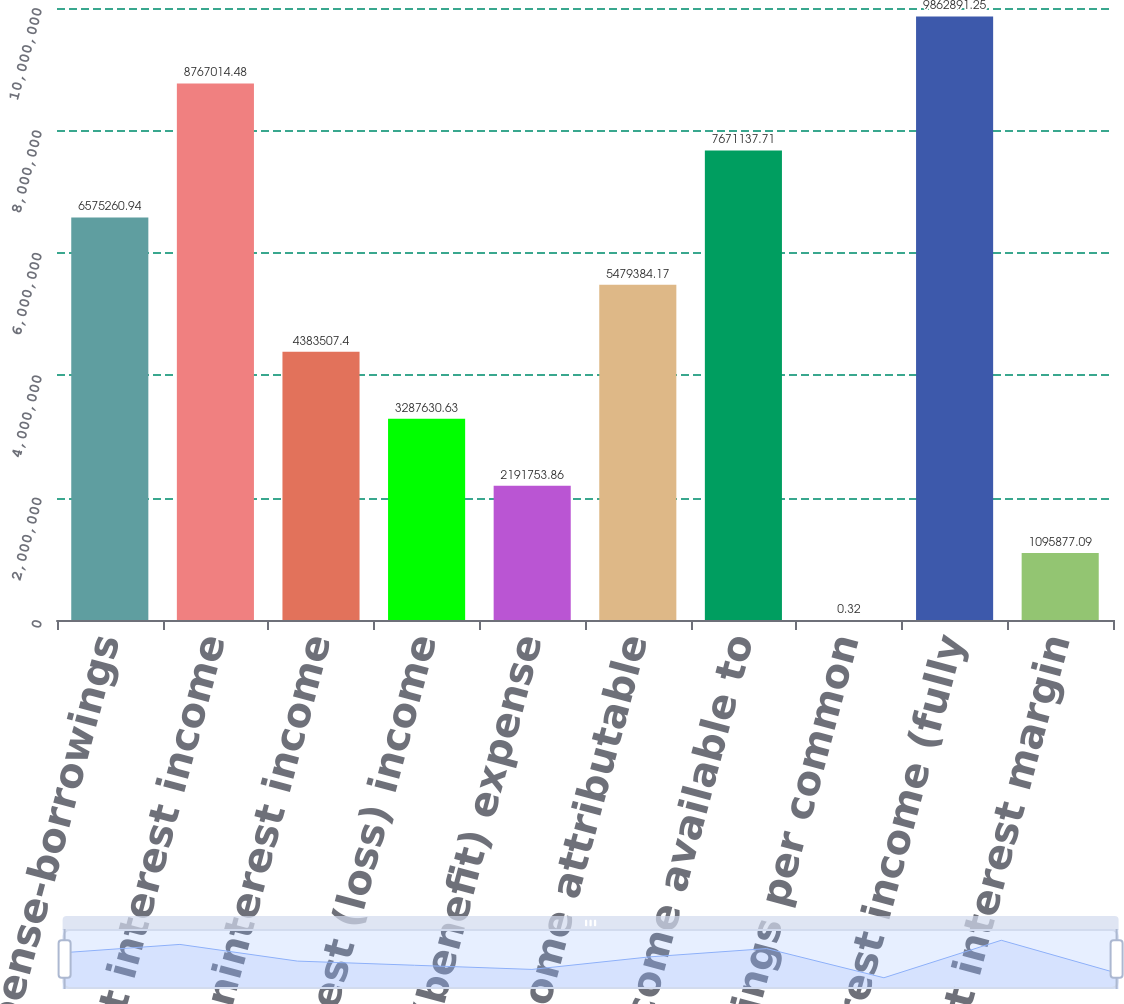<chart> <loc_0><loc_0><loc_500><loc_500><bar_chart><fcel>Interest expense-borrowings<fcel>Net interest income<fcel>Other noninterest income<fcel>Noninterest (loss) income<fcel>Income tax (benefit) expense<fcel>Net (loss) income attributable<fcel>Net (loss) income available to<fcel>(Loss) earnings per common<fcel>Net interest income (fully<fcel>Net interest margin<nl><fcel>6.57526e+06<fcel>8.76701e+06<fcel>4.38351e+06<fcel>3.28763e+06<fcel>2.19175e+06<fcel>5.47938e+06<fcel>7.67114e+06<fcel>0.32<fcel>9.86289e+06<fcel>1.09588e+06<nl></chart> 